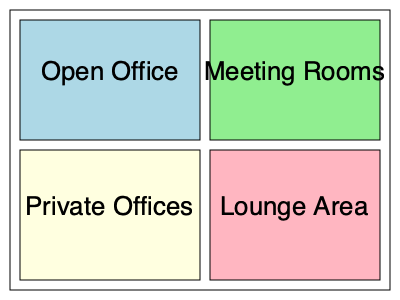As the CEO of a growing tech startup, you're planning to optimize your office space. The floor plan above shows different areas of your office. If you need to accommodate 40 employees in the Open Office area, and each employee requires a minimum of 5 square meters of space, what is the maximum number of meeting rooms you can fit in the Meeting Rooms area if each meeting room needs 15 square meters? To solve this problem, we need to follow these steps:

1. Calculate the area of the Open Office space:
   Length = 180 units, Width = 120 units
   Area = 180 * 120 = 21,600 square units

2. Convert the Open Office area to square meters:
   Let's assume 1 unit = 0.1 meters
   21,600 square units = 21,600 * (0.1 * 0.1) = 216 square meters

3. Calculate the space needed for 40 employees:
   40 employees * 5 square meters = 200 square meters

4. Verify if the Open Office space is sufficient:
   216 square meters > 200 square meters, so it's sufficient

5. Calculate the area of the Meeting Rooms space:
   Length = 170 units, Width = 120 units
   Area = 170 * 120 = 20,400 square units
   20,400 square units = 20,400 * (0.1 * 0.1) = 204 square meters

6. Calculate the number of meeting rooms that can fit:
   Number of rooms = Floor(204 / 15) = Floor(13.6) = 13

Therefore, the maximum number of meeting rooms that can fit in the Meeting Rooms area is 13.
Answer: 13 meeting rooms 